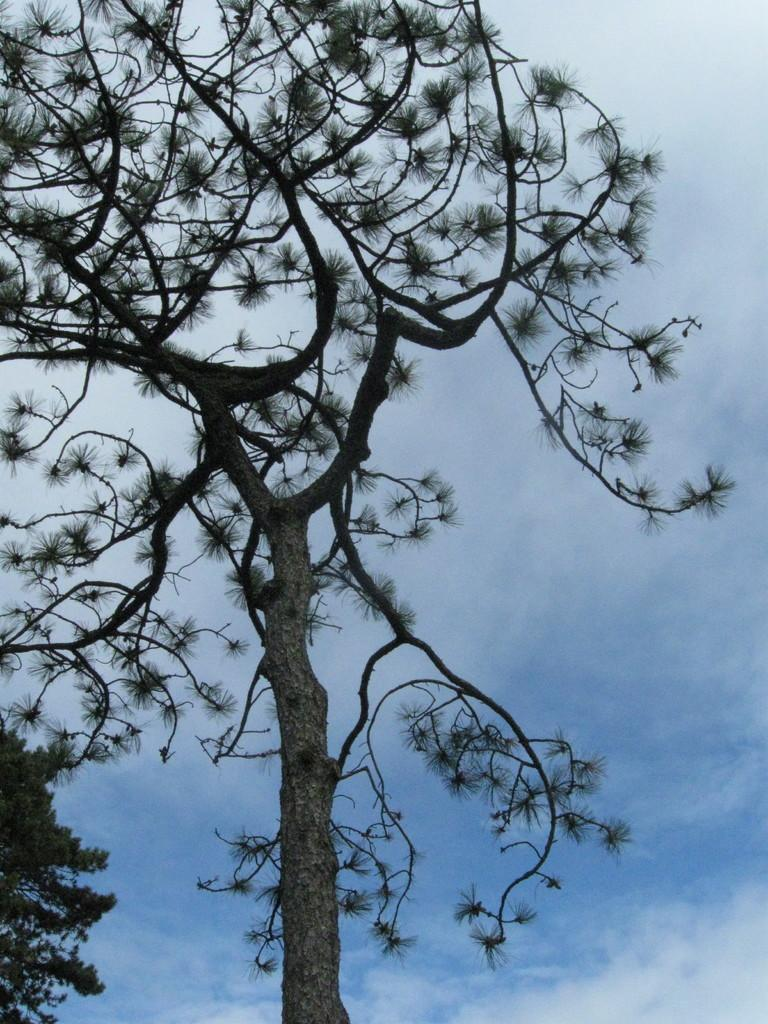What type of plant can be seen in the image? There is a tree in the image. What part of the natural environment is visible in the image? The sky is visible in the background of the image. Where is the shelf located in the image? There is no shelf present in the image. What type of creature can be seen lurking in the mist in the image? There is no mist or beast present in the image. 